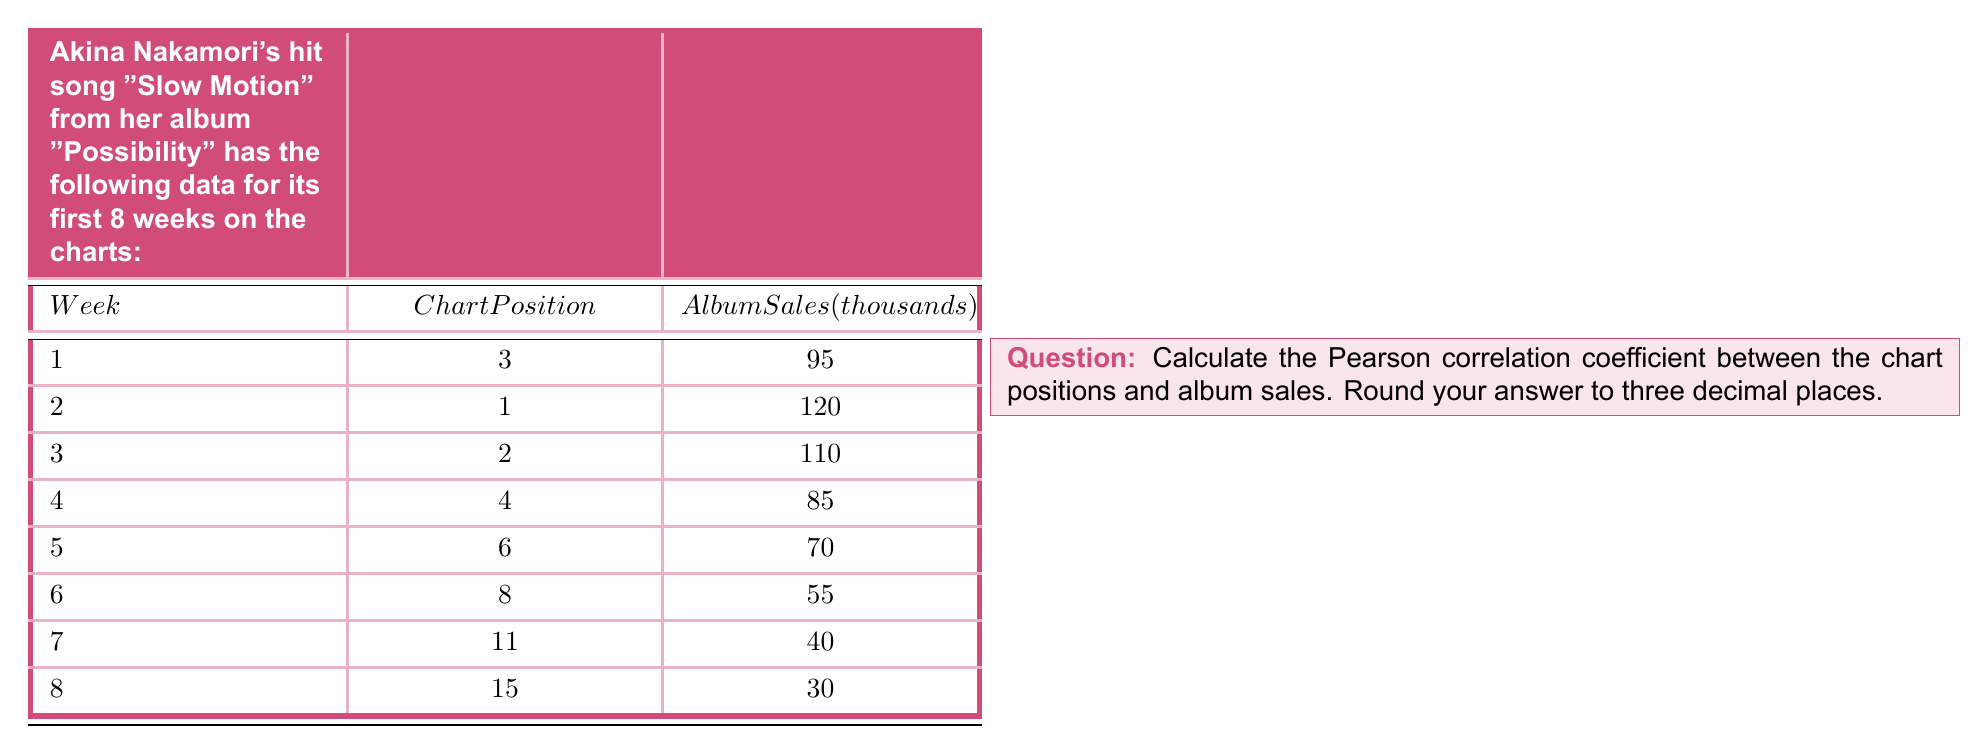Teach me how to tackle this problem. To calculate the Pearson correlation coefficient between chart positions and album sales, we'll follow these steps:

1. Calculate the means of chart positions ($\bar{x}$) and album sales ($\bar{y}$):

   $\bar{x} = \frac{3 + 1 + 2 + 4 + 6 + 8 + 11 + 15}{8} = 6.25$
   $\bar{y} = \frac{95 + 120 + 110 + 85 + 70 + 55 + 40 + 30}{8} = 75.625$

2. Calculate the deviations from the means:

   $x_i - \bar{x}$ and $y_i - \bar{y}$ for each data point

3. Calculate the products of the deviations and their sum:

   $\sum(x_i - \bar{x})(y_i - \bar{y})$

4. Calculate the squared deviations and their sums:

   $\sum(x_i - \bar{x})^2$ and $\sum(y_i - \bar{y})^2$

5. Apply the Pearson correlation coefficient formula:

   $r = \frac{\sum(x_i - \bar{x})(y_i - \bar{y})}{\sqrt{\sum(x_i - \bar{x})^2 \sum(y_i - \bar{y})^2}}$

Calculations:

$\sum(x_i - \bar{x})(y_i - \bar{y}) = 1181.25$
$\sum(x_i - \bar{x})^2 = 170.75$
$\sum(y_i - \bar{y})^2 = 9140.9375$

Substituting into the formula:

$r = \frac{1181.25}{\sqrt{170.75 \times 9140.9375}} = \frac{1181.25}{1250.4989}$

$r \approx -0.944$ (rounded to three decimal places)

The negative sign indicates an inverse relationship: as chart position increases (lower rank), album sales decrease.
Answer: $-0.944$ 